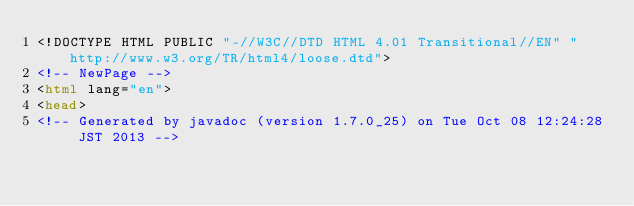Convert code to text. <code><loc_0><loc_0><loc_500><loc_500><_HTML_><!DOCTYPE HTML PUBLIC "-//W3C//DTD HTML 4.01 Transitional//EN" "http://www.w3.org/TR/html4/loose.dtd">
<!-- NewPage -->
<html lang="en">
<head>
<!-- Generated by javadoc (version 1.7.0_25) on Tue Oct 08 12:24:28 JST 2013 --></code> 